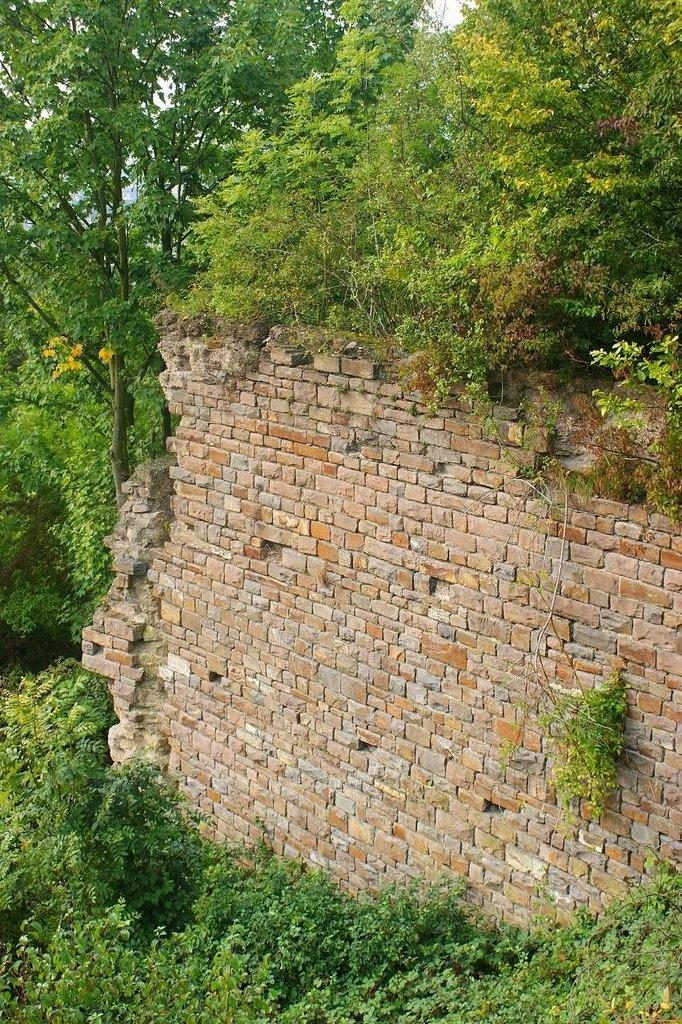What type of structure is in the middle of the image? There is a brick wall in the middle of the image. Where are the plants located in relation to the wall? The plants are around the wall. What type of rabbit can be seen using a hammer on the wall in the image? There is no rabbit or hammer present in the image; it features a brick wall with plants around it. 